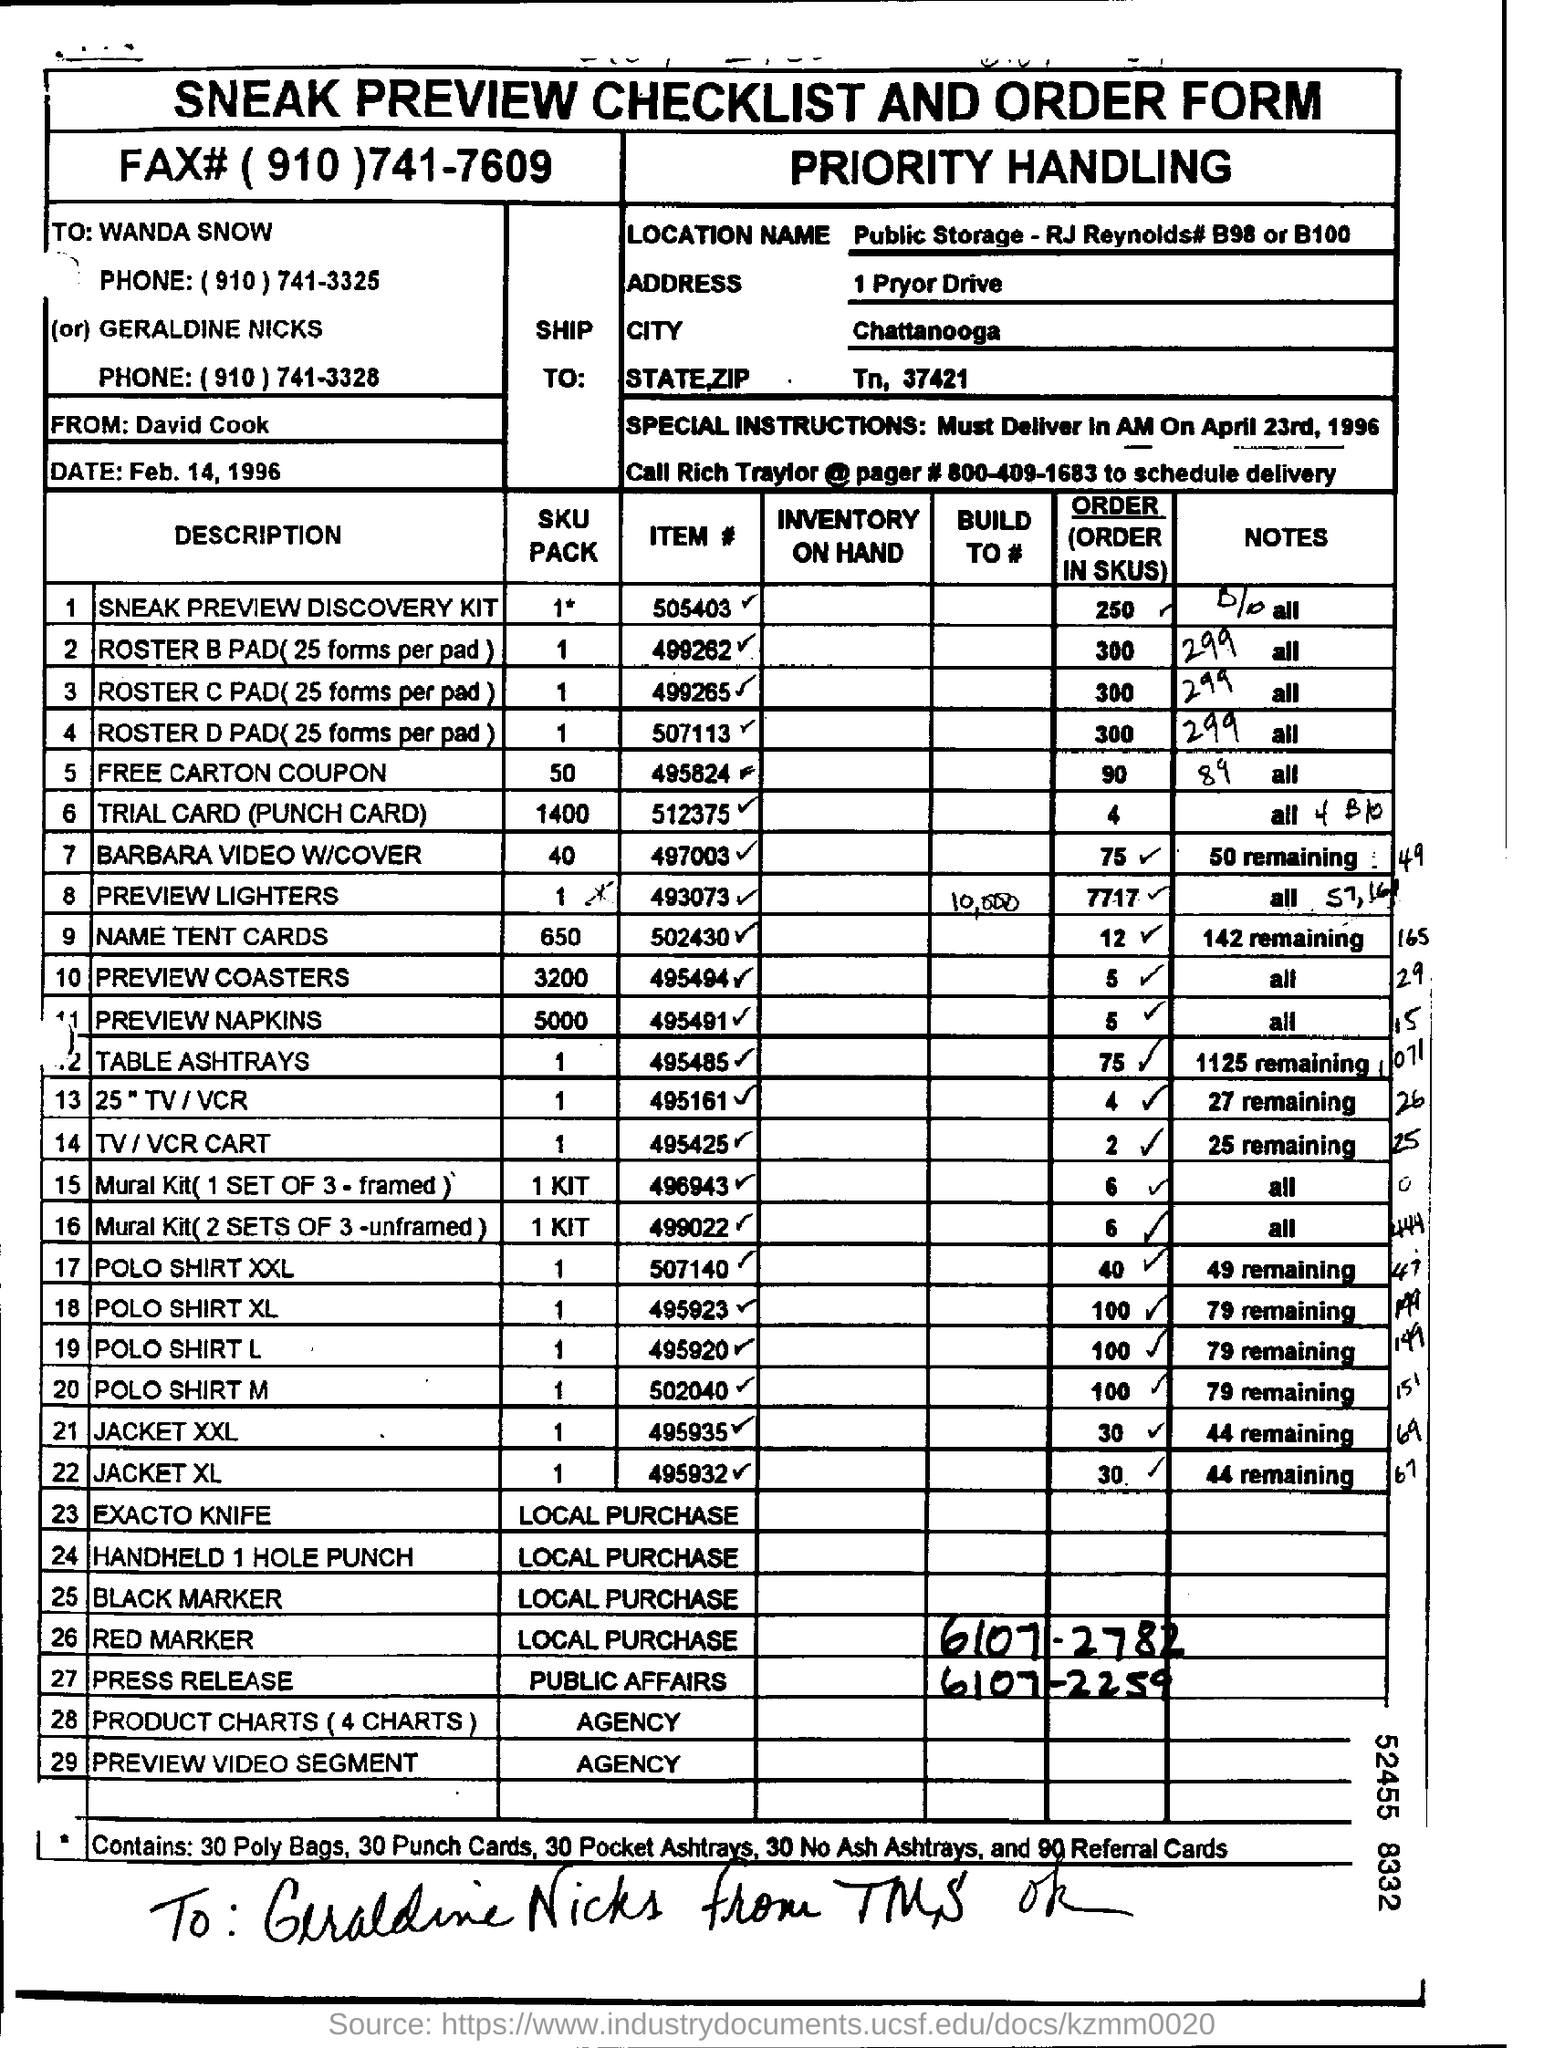What is the heading of the document?
Offer a terse response. SNEAK PREVIEW CHECKLIST AND ORDER FORM. What is the LOCATION NAME?
Provide a succinct answer. Public Storage - RJ Reynolds# B98 or B100. What is the name of the CITY mentioned?
Provide a short and direct response. Chattanooga. 